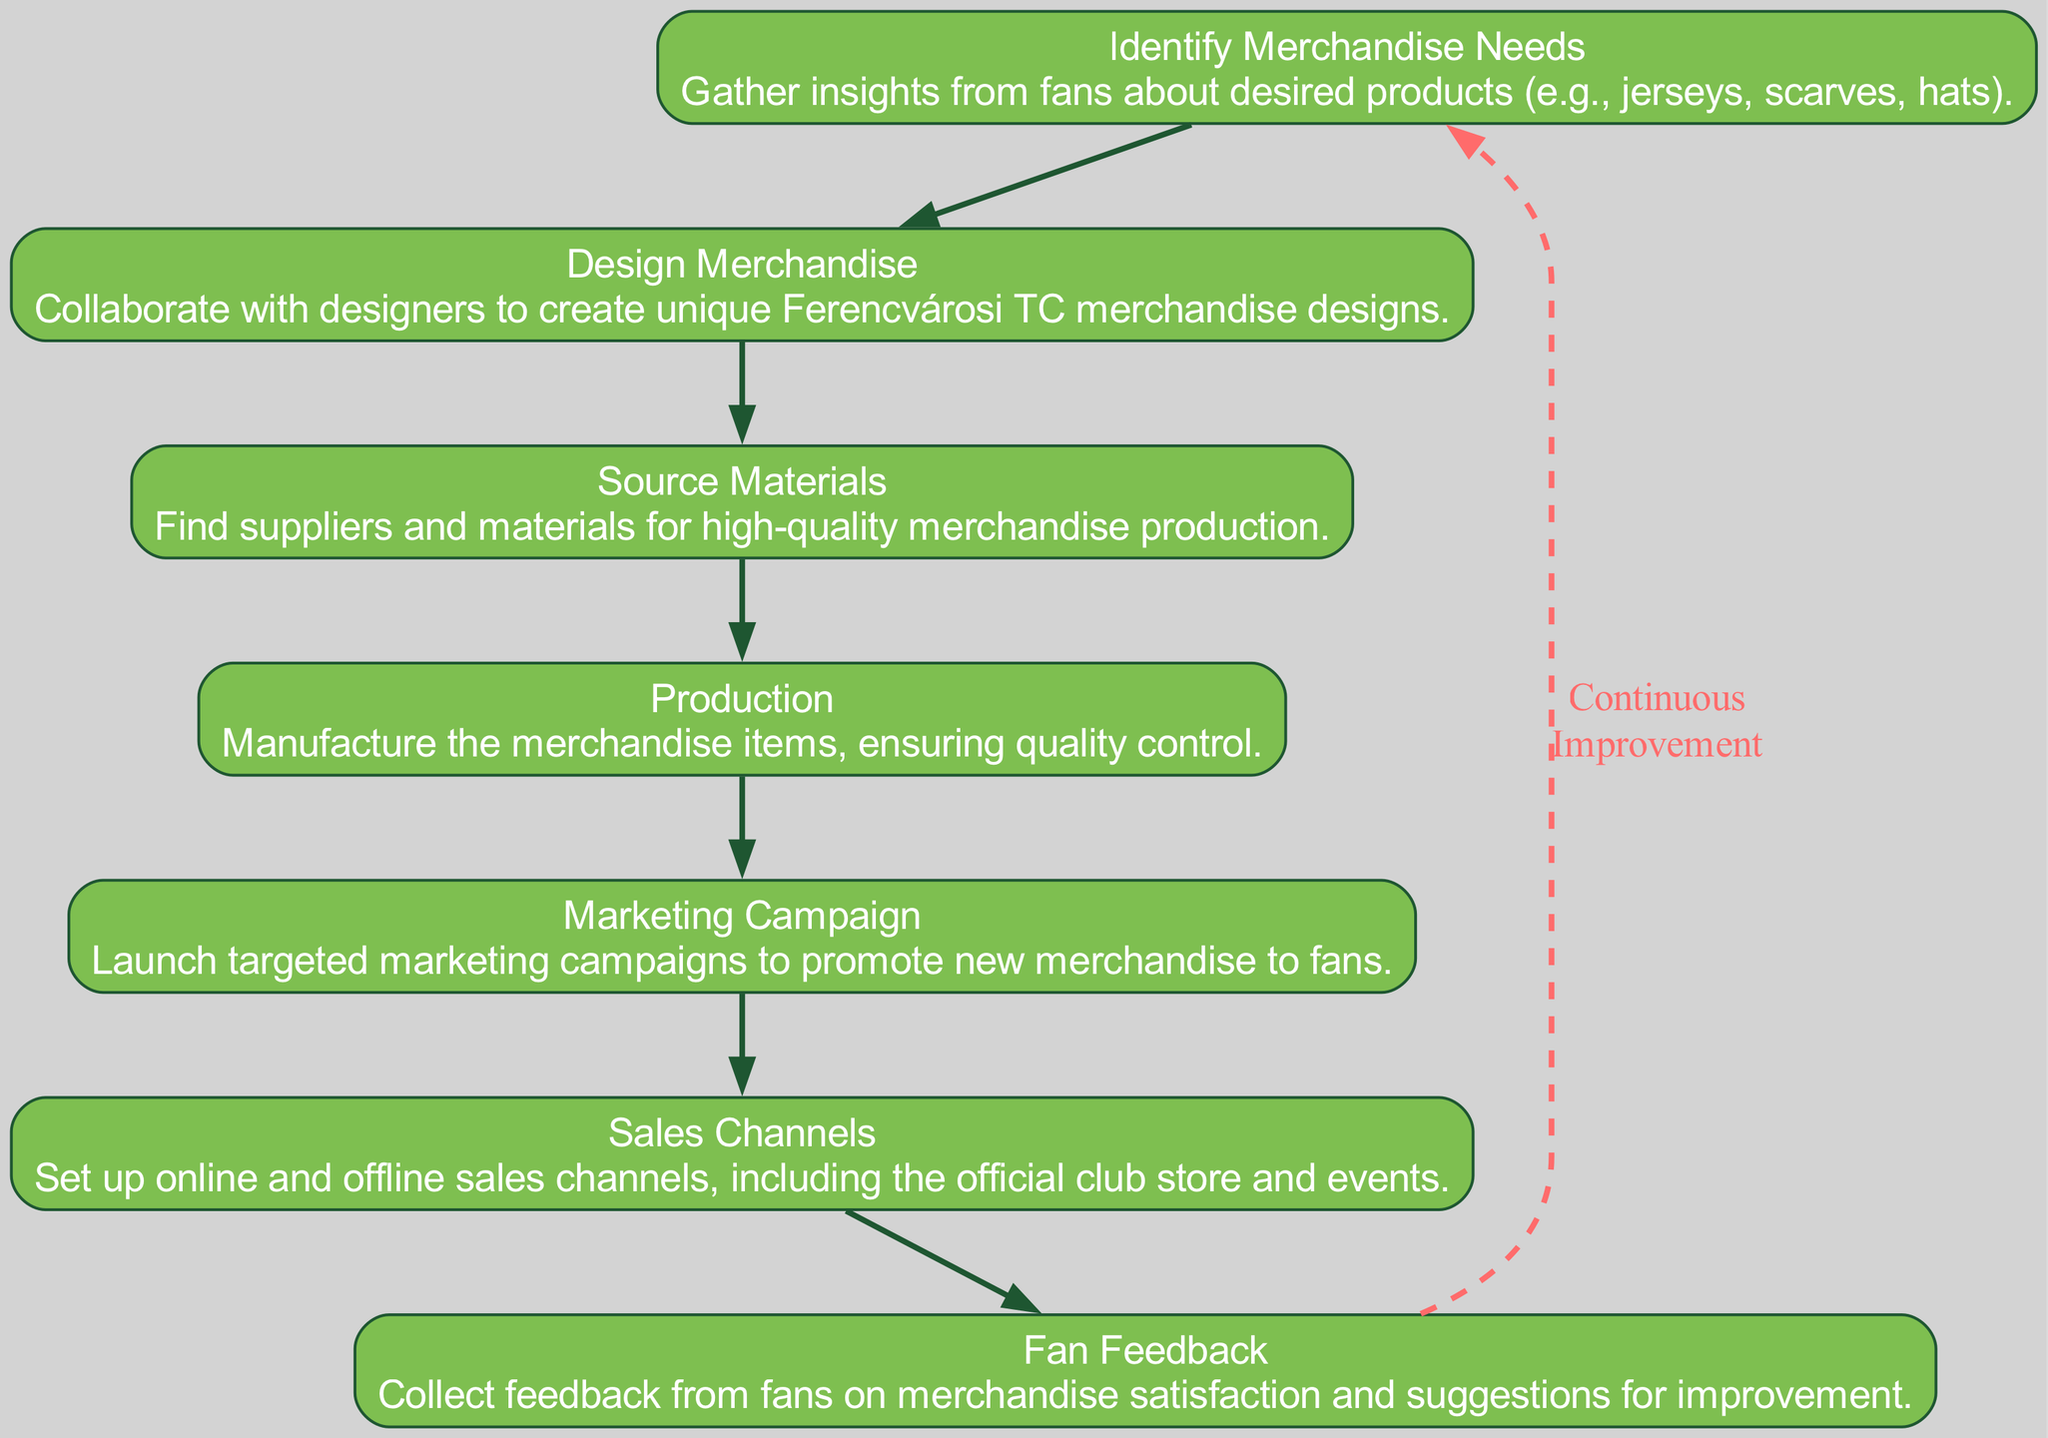What is the first step in the merchandising process? The first step in the merchandising process is indicated by the first node in the flow chart, which states "Identify Merchandise Needs." This is where insights are gathered from fans about desired products.
Answer: Identify Merchandise Needs How many steps are there in total in the process? To determine the total number of steps, count the distinct nodes present in the diagram. There are seven nodes outlining different steps in the merchandising process.
Answer: Seven Which step follows "Design Merchandise"? By examining the flow chart, the step that comes after "Design Merchandise" leads to "Source Materials." This sequential connection is shown by the directed edge between these two nodes.
Answer: Source Materials What type of edge connects the last step to the first step? The diagram has a dashed edge labeled "Continuous Improvement" connecting the last node, "Fan Feedback," back to the first node, "Identify Merchandise Needs." This indicates a cyclical nature of the process.
Answer: Dashed edge What is the purpose of the "Marketing Campaign" step? The purpose of the "Marketing Campaign" step is explained in its description, which highlights launching targeted campaigns to promote new merchandise specifically to fans. This clarifies its role within the overall process.
Answer: Promote merchandise How does "Fan Feedback" contribute to the process? "Fan Feedback" is crucial as it allows the club to collect fans' opinions on merchandise satisfaction and gain suggestions for improvement, which can influence future merchandise decisions, completing the cycle of feedback.
Answer: Suggestions for improvement Which two steps are directly linked by an edge indicating a sequential relationship? The steps that are directly linked by an edge in a sequential relationship include "Production" leading to "Marketing Campaign." This demonstrates the flow from manufacturing to promoting the products.
Answer: Production to Marketing Campaign What does the "Source Materials" step entail? The "Source Materials" step involves finding suppliers and high-quality materials necessary for manufacturing the merchandise items, as indicated in its description. This establishes its significance in ensuring product quality.
Answer: Find suppliers and materials How does the process ensure quality control? Quality control is ensured during the "Production" step where the merchandise items are manufactured. The description emphasizes that this step includes ensuring quality standards are met during production.
Answer: Quality control in Production 